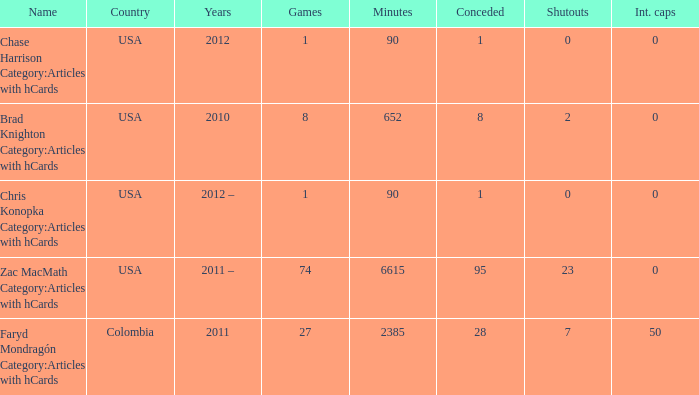With 2010 being the year, what is the recreation? 8.0. 